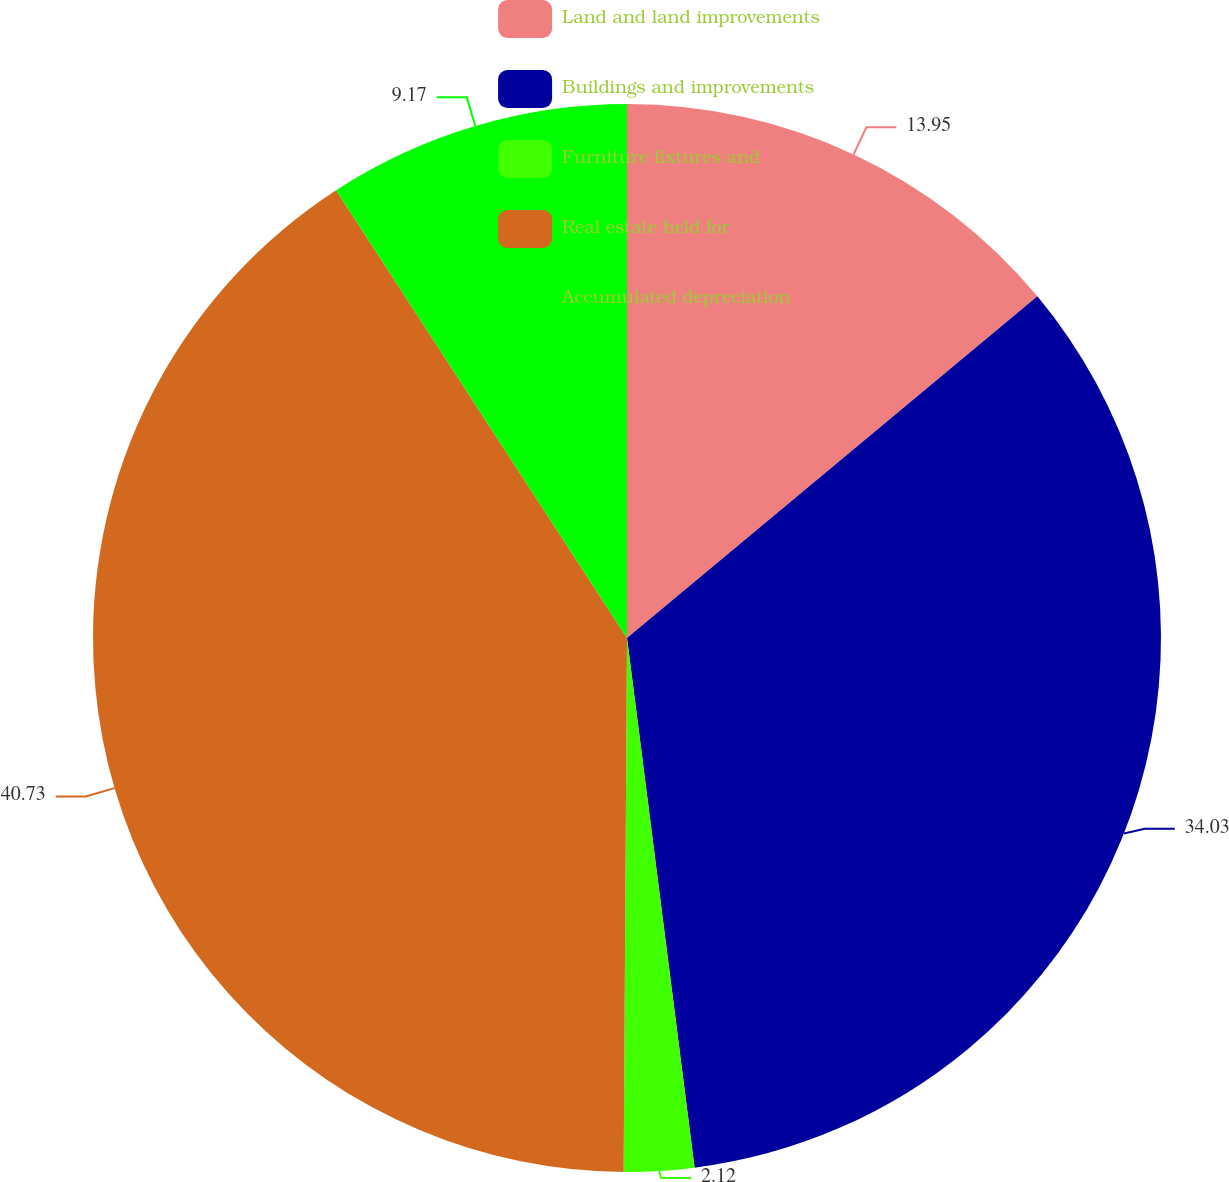Convert chart. <chart><loc_0><loc_0><loc_500><loc_500><pie_chart><fcel>Land and land improvements<fcel>Buildings and improvements<fcel>Furniture fixtures and<fcel>Real estate held for<fcel>Accumulated depreciation<nl><fcel>13.95%<fcel>34.03%<fcel>2.12%<fcel>40.73%<fcel>9.17%<nl></chart> 